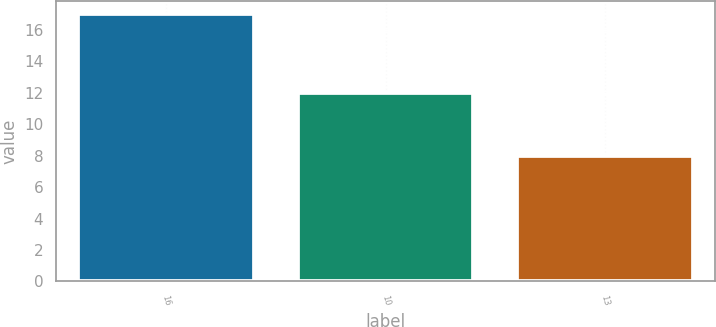Convert chart to OTSL. <chart><loc_0><loc_0><loc_500><loc_500><bar_chart><fcel>16<fcel>10<fcel>13<nl><fcel>17<fcel>12<fcel>8<nl></chart> 